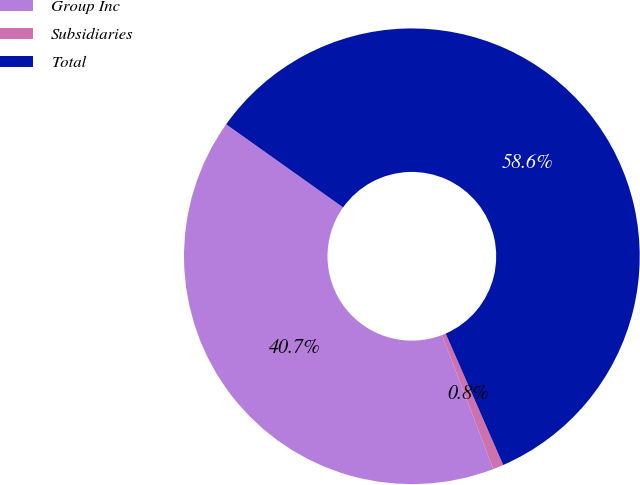<chart> <loc_0><loc_0><loc_500><loc_500><pie_chart><fcel>Group Inc<fcel>Subsidiaries<fcel>Total<nl><fcel>40.65%<fcel>0.75%<fcel>58.6%<nl></chart> 